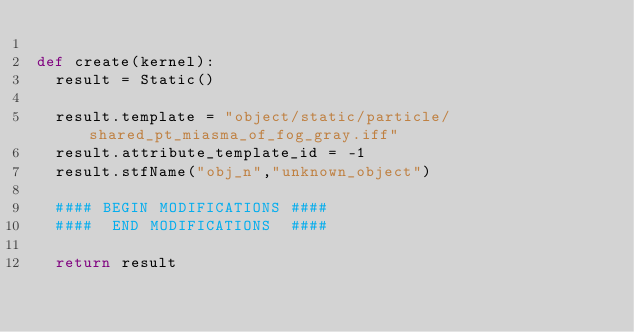Convert code to text. <code><loc_0><loc_0><loc_500><loc_500><_Python_>
def create(kernel):
	result = Static()

	result.template = "object/static/particle/shared_pt_miasma_of_fog_gray.iff"
	result.attribute_template_id = -1
	result.stfName("obj_n","unknown_object")		
	
	#### BEGIN MODIFICATIONS ####
	####  END MODIFICATIONS  ####
	
	return result</code> 